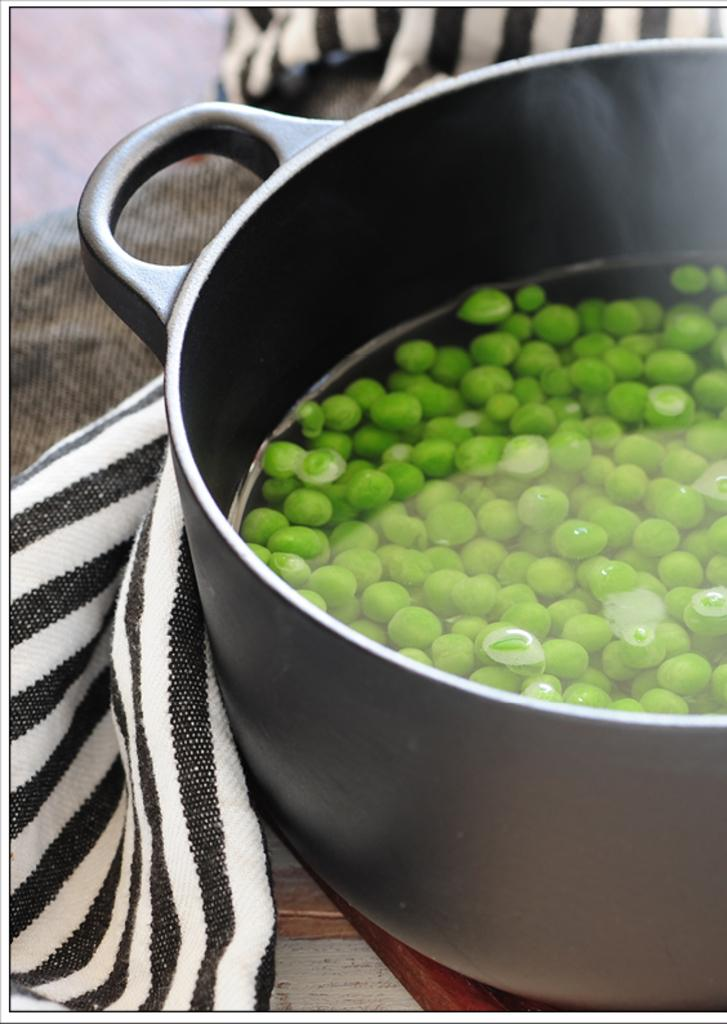What is in the bowl that is visible in the image? There is a bowl in the image, and it contains water. What else can be seen in the water? There are green pulses in the water. Is there anything else present on the surface of the bowl? Yes, a cloth is present on the surface of the bowl. What type of rail can be seen in the image? There is no rail present in the image; it features a bowl with water and green pulses. What news is being reported in the image? There is no news being reported in the image; it features a bowl with water and green pulses. 